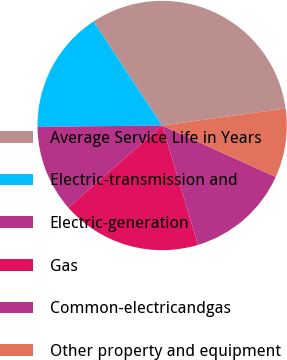Convert chart to OTSL. <chart><loc_0><loc_0><loc_500><loc_500><pie_chart><fcel>Average Service Life in Years<fcel>Electric-transmission and<fcel>Electric-generation<fcel>Gas<fcel>Common-electricandgas<fcel>Other property and equipment<nl><fcel>32.11%<fcel>15.89%<fcel>11.26%<fcel>18.21%<fcel>13.58%<fcel>8.95%<nl></chart> 